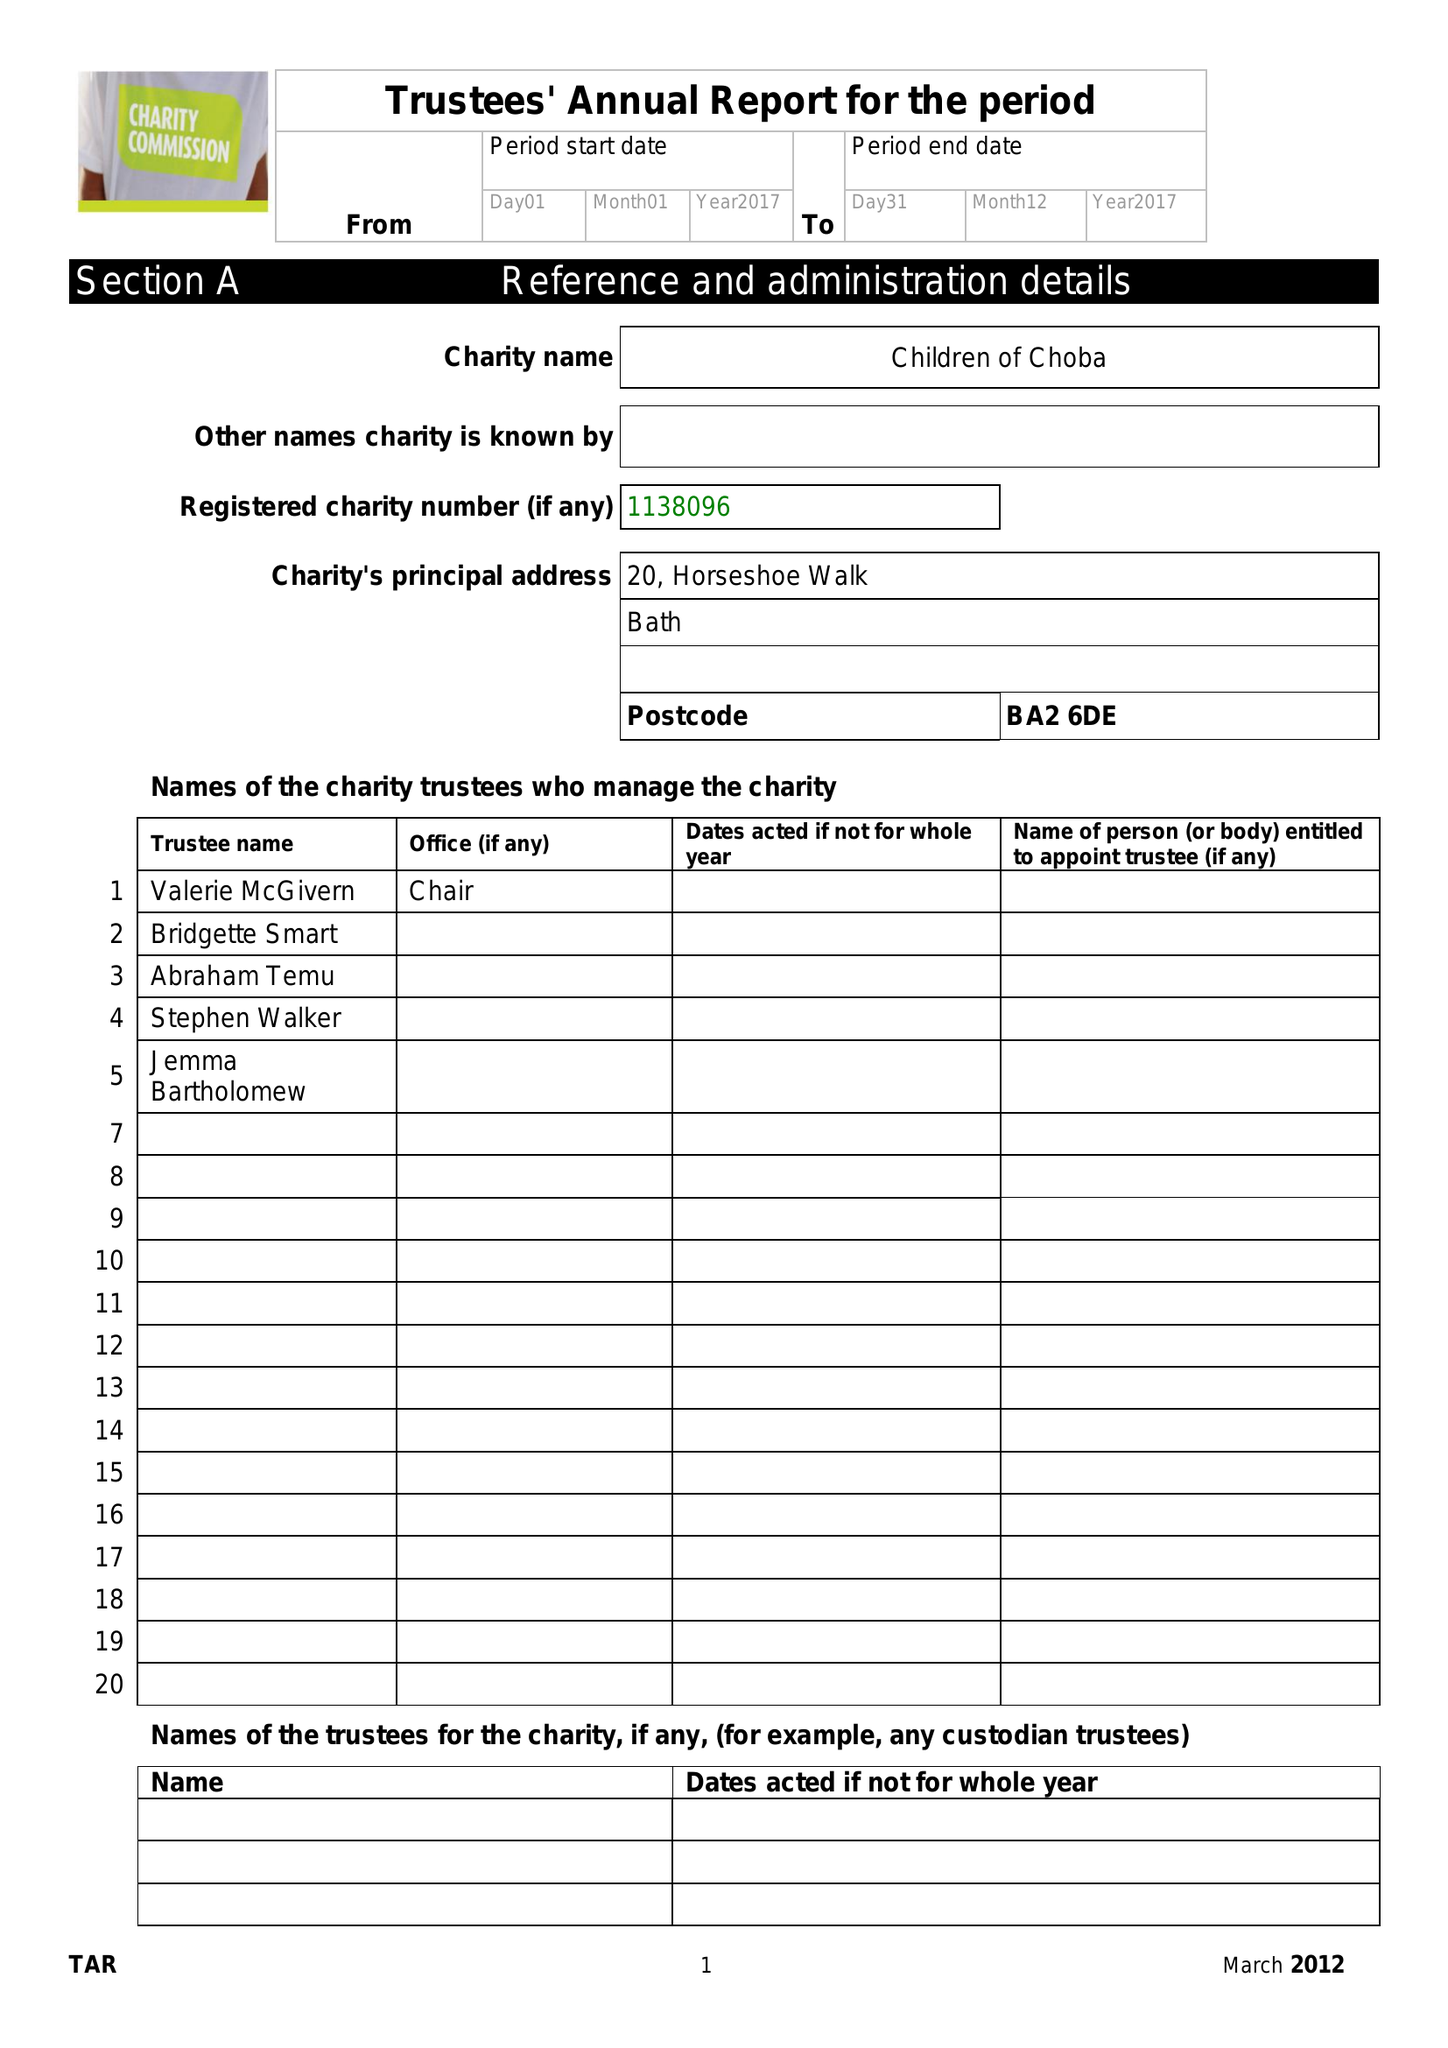What is the value for the address__postcode?
Answer the question using a single word or phrase. BA2 6DE 